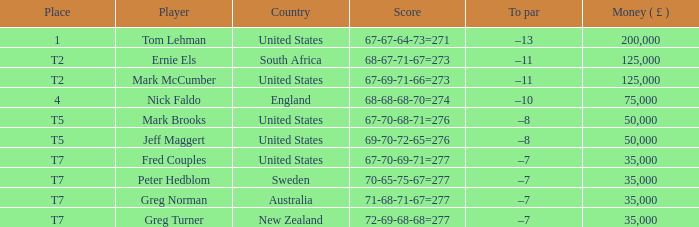When peter hedblom is the player, what is the greatest sum of money (£) he has won? 35000.0. 